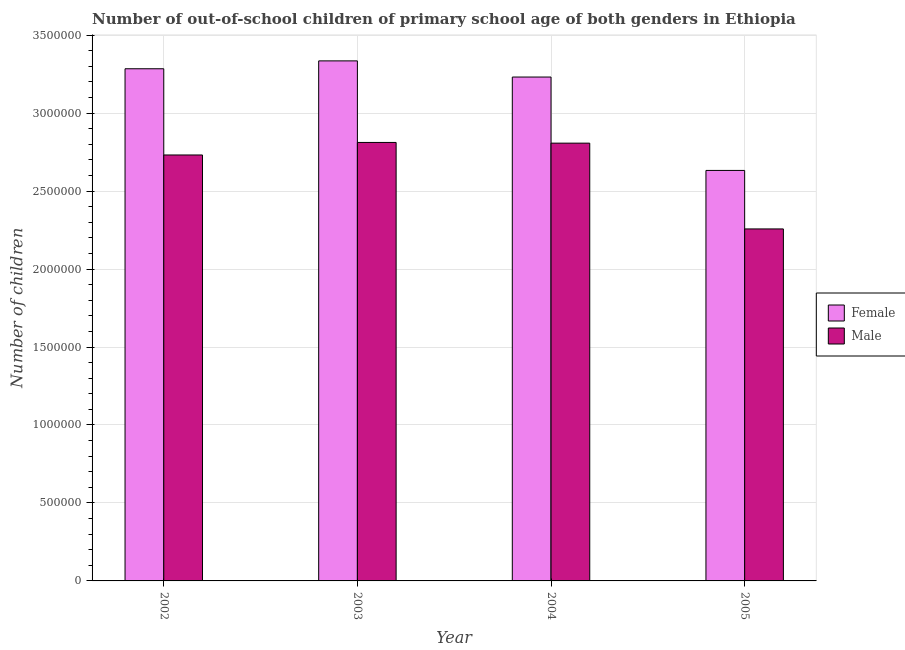How many different coloured bars are there?
Provide a succinct answer. 2. How many groups of bars are there?
Give a very brief answer. 4. Are the number of bars on each tick of the X-axis equal?
Your answer should be very brief. Yes. What is the label of the 1st group of bars from the left?
Provide a succinct answer. 2002. What is the number of male out-of-school students in 2004?
Your response must be concise. 2.81e+06. Across all years, what is the maximum number of female out-of-school students?
Provide a succinct answer. 3.34e+06. Across all years, what is the minimum number of female out-of-school students?
Keep it short and to the point. 2.63e+06. In which year was the number of male out-of-school students maximum?
Give a very brief answer. 2003. What is the total number of female out-of-school students in the graph?
Make the answer very short. 1.25e+07. What is the difference between the number of male out-of-school students in 2002 and that in 2004?
Give a very brief answer. -7.58e+04. What is the difference between the number of female out-of-school students in 2003 and the number of male out-of-school students in 2005?
Offer a terse response. 7.03e+05. What is the average number of male out-of-school students per year?
Provide a succinct answer. 2.65e+06. In how many years, is the number of female out-of-school students greater than 300000?
Offer a terse response. 4. What is the ratio of the number of female out-of-school students in 2002 to that in 2005?
Ensure brevity in your answer.  1.25. Is the number of female out-of-school students in 2002 less than that in 2005?
Your answer should be compact. No. What is the difference between the highest and the second highest number of male out-of-school students?
Offer a very short reply. 4508. What is the difference between the highest and the lowest number of male out-of-school students?
Offer a terse response. 5.55e+05. In how many years, is the number of male out-of-school students greater than the average number of male out-of-school students taken over all years?
Your response must be concise. 3. Is the sum of the number of male out-of-school students in 2004 and 2005 greater than the maximum number of female out-of-school students across all years?
Offer a terse response. Yes. What does the 2nd bar from the right in 2002 represents?
Give a very brief answer. Female. How many bars are there?
Your answer should be very brief. 8. How many years are there in the graph?
Keep it short and to the point. 4. What is the difference between two consecutive major ticks on the Y-axis?
Provide a succinct answer. 5.00e+05. Are the values on the major ticks of Y-axis written in scientific E-notation?
Offer a terse response. No. Does the graph contain any zero values?
Offer a very short reply. No. Does the graph contain grids?
Provide a short and direct response. Yes. Where does the legend appear in the graph?
Make the answer very short. Center right. How many legend labels are there?
Offer a terse response. 2. How are the legend labels stacked?
Your answer should be very brief. Vertical. What is the title of the graph?
Keep it short and to the point. Number of out-of-school children of primary school age of both genders in Ethiopia. Does "RDB concessional" appear as one of the legend labels in the graph?
Your answer should be compact. No. What is the label or title of the X-axis?
Your response must be concise. Year. What is the label or title of the Y-axis?
Make the answer very short. Number of children. What is the Number of children of Female in 2002?
Give a very brief answer. 3.28e+06. What is the Number of children of Male in 2002?
Offer a very short reply. 2.73e+06. What is the Number of children in Female in 2003?
Your answer should be compact. 3.34e+06. What is the Number of children of Male in 2003?
Your response must be concise. 2.81e+06. What is the Number of children in Female in 2004?
Give a very brief answer. 3.23e+06. What is the Number of children of Male in 2004?
Keep it short and to the point. 2.81e+06. What is the Number of children of Female in 2005?
Offer a very short reply. 2.63e+06. What is the Number of children in Male in 2005?
Give a very brief answer. 2.26e+06. Across all years, what is the maximum Number of children of Female?
Make the answer very short. 3.34e+06. Across all years, what is the maximum Number of children in Male?
Provide a short and direct response. 2.81e+06. Across all years, what is the minimum Number of children in Female?
Your response must be concise. 2.63e+06. Across all years, what is the minimum Number of children of Male?
Ensure brevity in your answer.  2.26e+06. What is the total Number of children in Female in the graph?
Keep it short and to the point. 1.25e+07. What is the total Number of children in Male in the graph?
Your answer should be compact. 1.06e+07. What is the difference between the Number of children in Female in 2002 and that in 2003?
Your answer should be very brief. -5.06e+04. What is the difference between the Number of children in Male in 2002 and that in 2003?
Provide a succinct answer. -8.03e+04. What is the difference between the Number of children in Female in 2002 and that in 2004?
Offer a terse response. 5.31e+04. What is the difference between the Number of children of Male in 2002 and that in 2004?
Your response must be concise. -7.58e+04. What is the difference between the Number of children of Female in 2002 and that in 2005?
Make the answer very short. 6.52e+05. What is the difference between the Number of children of Male in 2002 and that in 2005?
Your answer should be very brief. 4.74e+05. What is the difference between the Number of children of Female in 2003 and that in 2004?
Your response must be concise. 1.04e+05. What is the difference between the Number of children of Male in 2003 and that in 2004?
Offer a terse response. 4508. What is the difference between the Number of children of Female in 2003 and that in 2005?
Offer a terse response. 7.03e+05. What is the difference between the Number of children of Male in 2003 and that in 2005?
Keep it short and to the point. 5.55e+05. What is the difference between the Number of children in Female in 2004 and that in 2005?
Make the answer very short. 5.99e+05. What is the difference between the Number of children in Male in 2004 and that in 2005?
Provide a short and direct response. 5.50e+05. What is the difference between the Number of children in Female in 2002 and the Number of children in Male in 2003?
Your answer should be very brief. 4.73e+05. What is the difference between the Number of children in Female in 2002 and the Number of children in Male in 2004?
Your response must be concise. 4.77e+05. What is the difference between the Number of children in Female in 2002 and the Number of children in Male in 2005?
Provide a short and direct response. 1.03e+06. What is the difference between the Number of children in Female in 2003 and the Number of children in Male in 2004?
Provide a succinct answer. 5.28e+05. What is the difference between the Number of children of Female in 2003 and the Number of children of Male in 2005?
Your response must be concise. 1.08e+06. What is the difference between the Number of children in Female in 2004 and the Number of children in Male in 2005?
Make the answer very short. 9.74e+05. What is the average Number of children in Female per year?
Ensure brevity in your answer.  3.12e+06. What is the average Number of children of Male per year?
Make the answer very short. 2.65e+06. In the year 2002, what is the difference between the Number of children in Female and Number of children in Male?
Provide a short and direct response. 5.53e+05. In the year 2003, what is the difference between the Number of children of Female and Number of children of Male?
Your response must be concise. 5.23e+05. In the year 2004, what is the difference between the Number of children in Female and Number of children in Male?
Offer a very short reply. 4.24e+05. In the year 2005, what is the difference between the Number of children of Female and Number of children of Male?
Keep it short and to the point. 3.75e+05. What is the ratio of the Number of children of Female in 2002 to that in 2003?
Offer a terse response. 0.98. What is the ratio of the Number of children of Male in 2002 to that in 2003?
Your response must be concise. 0.97. What is the ratio of the Number of children in Female in 2002 to that in 2004?
Your answer should be very brief. 1.02. What is the ratio of the Number of children in Male in 2002 to that in 2004?
Provide a short and direct response. 0.97. What is the ratio of the Number of children in Female in 2002 to that in 2005?
Ensure brevity in your answer.  1.25. What is the ratio of the Number of children in Male in 2002 to that in 2005?
Ensure brevity in your answer.  1.21. What is the ratio of the Number of children in Female in 2003 to that in 2004?
Provide a succinct answer. 1.03. What is the ratio of the Number of children of Male in 2003 to that in 2004?
Offer a very short reply. 1. What is the ratio of the Number of children of Female in 2003 to that in 2005?
Make the answer very short. 1.27. What is the ratio of the Number of children of Male in 2003 to that in 2005?
Your answer should be compact. 1.25. What is the ratio of the Number of children in Female in 2004 to that in 2005?
Your answer should be compact. 1.23. What is the ratio of the Number of children in Male in 2004 to that in 2005?
Offer a terse response. 1.24. What is the difference between the highest and the second highest Number of children of Female?
Provide a short and direct response. 5.06e+04. What is the difference between the highest and the second highest Number of children of Male?
Keep it short and to the point. 4508. What is the difference between the highest and the lowest Number of children of Female?
Provide a succinct answer. 7.03e+05. What is the difference between the highest and the lowest Number of children of Male?
Your answer should be very brief. 5.55e+05. 